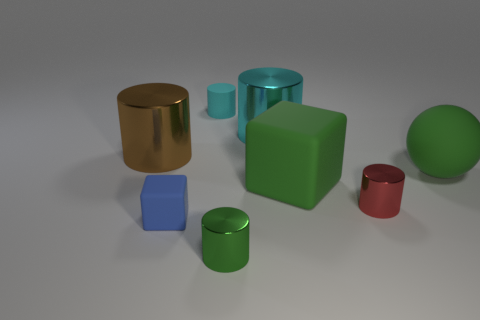How many objects are metallic things or cylinders that are to the right of the large brown metallic object? To the right of the large brown metallic cylinder, there are four objects that fit the criteria: one metallic cylinder with a blue tint, two solid cylinders (one green and one red), and a metallic cube. So, there are a total of four items that are either metallic or cylindrical to the right of the large brown object. 